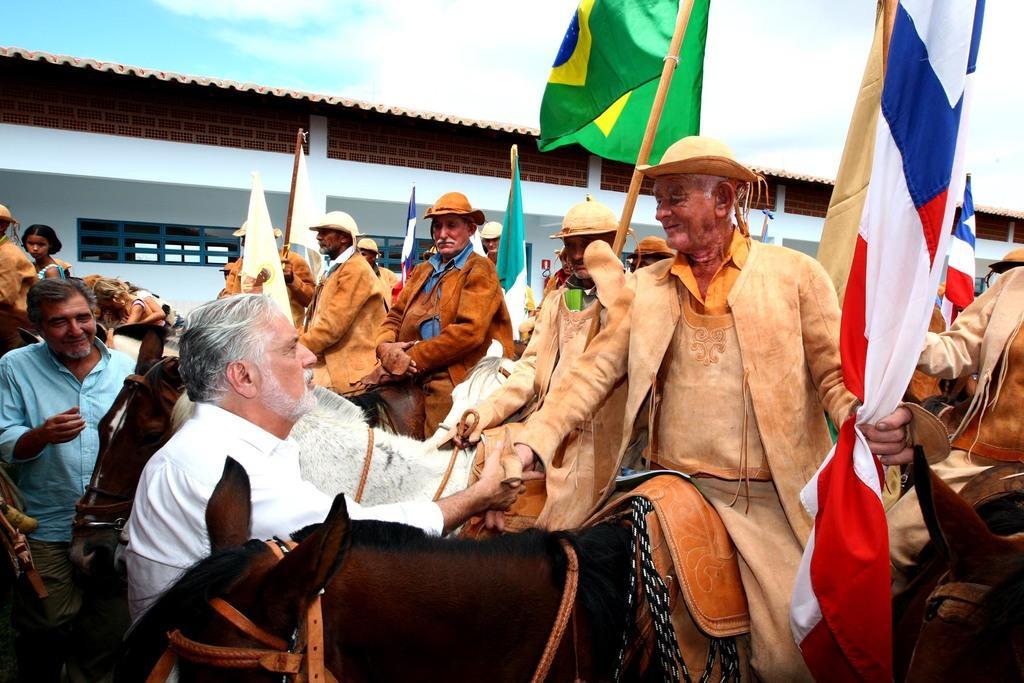Can you describe this image briefly? In this picture we can see group of people, few are standing, and few are seated on the horse, and they hold flag in their hands, in the background we can see a building. 